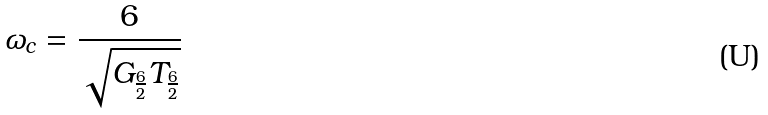Convert formula to latex. <formula><loc_0><loc_0><loc_500><loc_500>\omega _ { c } = \frac { 6 } { \sqrt { G _ { \frac { 6 } { 2 } } T _ { \frac { 6 } { 2 } } } }</formula> 